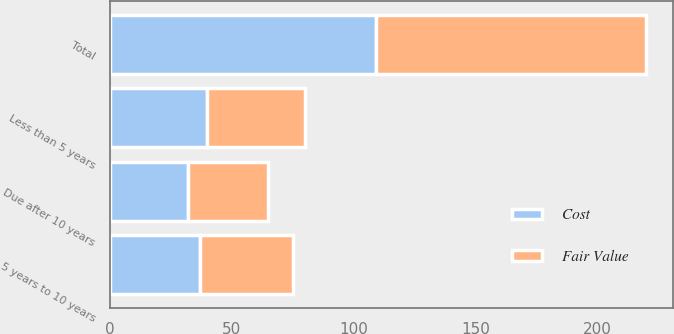Convert chart to OTSL. <chart><loc_0><loc_0><loc_500><loc_500><stacked_bar_chart><ecel><fcel>Less than 5 years<fcel>5 years to 10 years<fcel>Due after 10 years<fcel>Total<nl><fcel>Cost<fcel>40<fcel>37<fcel>32<fcel>109<nl><fcel>Fair Value<fcel>40<fcel>38<fcel>33<fcel>111<nl></chart> 